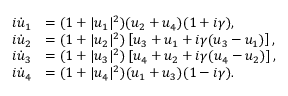<formula> <loc_0><loc_0><loc_500><loc_500>\begin{array} { r l } { i \dot { u } _ { 1 } } & { = ( 1 + | u _ { 1 } | ^ { 2 } ) ( u _ { 2 } + u _ { 4 } ) ( 1 + i \gamma ) , } \\ { i \dot { u } _ { 2 } } & { = ( 1 + | u _ { 2 } | ^ { 2 } ) \left [ u _ { 3 } + u _ { 1 } + i \gamma ( u _ { 3 } - u _ { 1 } ) \right ] , } \\ { i \dot { u } _ { 3 } } & { = ( 1 + | u _ { 3 } | ^ { 2 } ) \left [ u _ { 4 } + u _ { 2 } + i \gamma ( u _ { 4 } - u _ { 2 } ) \right ] , } \\ { i \dot { u } _ { 4 } } & { = ( 1 + | u _ { 4 } | ^ { 2 } ) ( u _ { 1 } + u _ { 3 } ) ( 1 - i \gamma ) . } \end{array}</formula> 